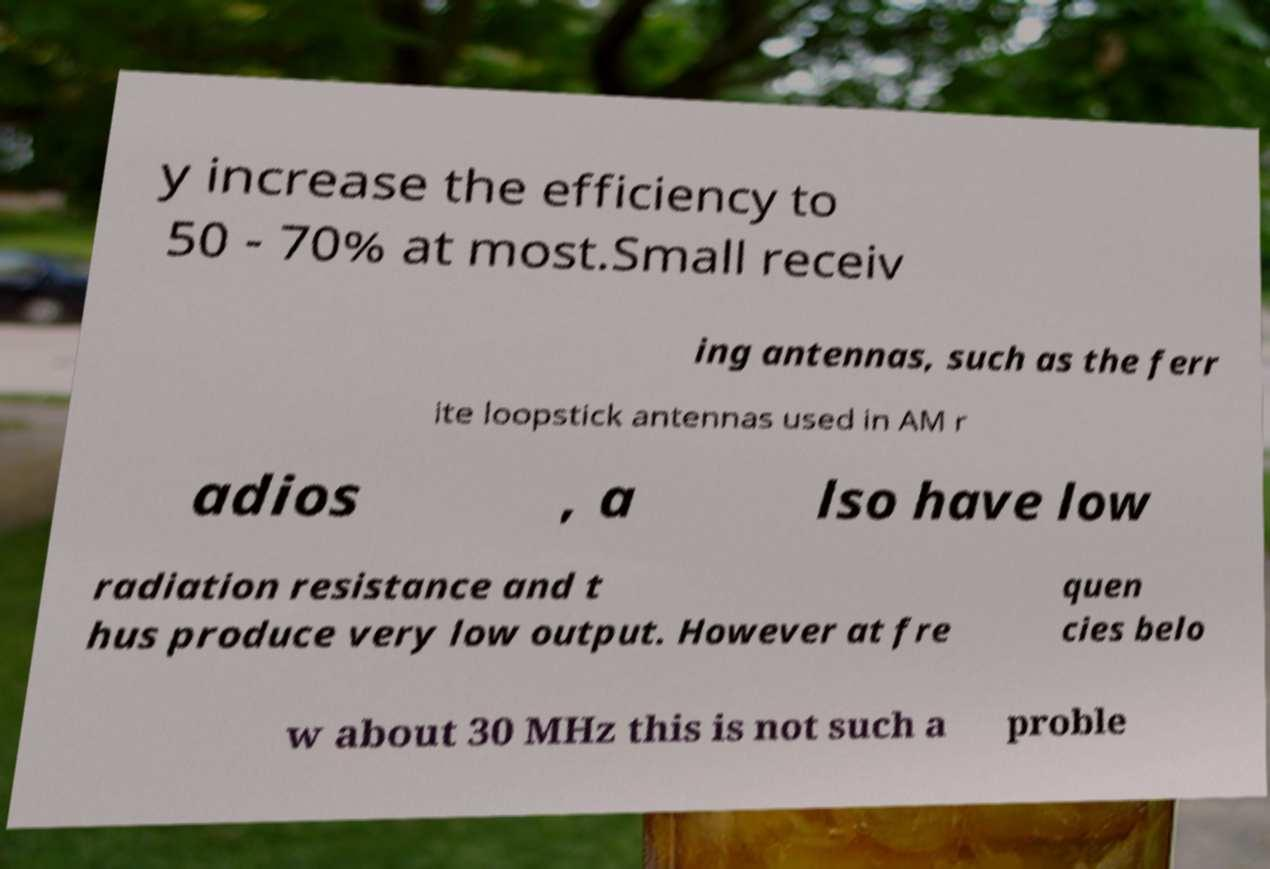There's text embedded in this image that I need extracted. Can you transcribe it verbatim? y increase the efficiency to 50 - 70% at most.Small receiv ing antennas, such as the ferr ite loopstick antennas used in AM r adios , a lso have low radiation resistance and t hus produce very low output. However at fre quen cies belo w about 30 MHz this is not such a proble 